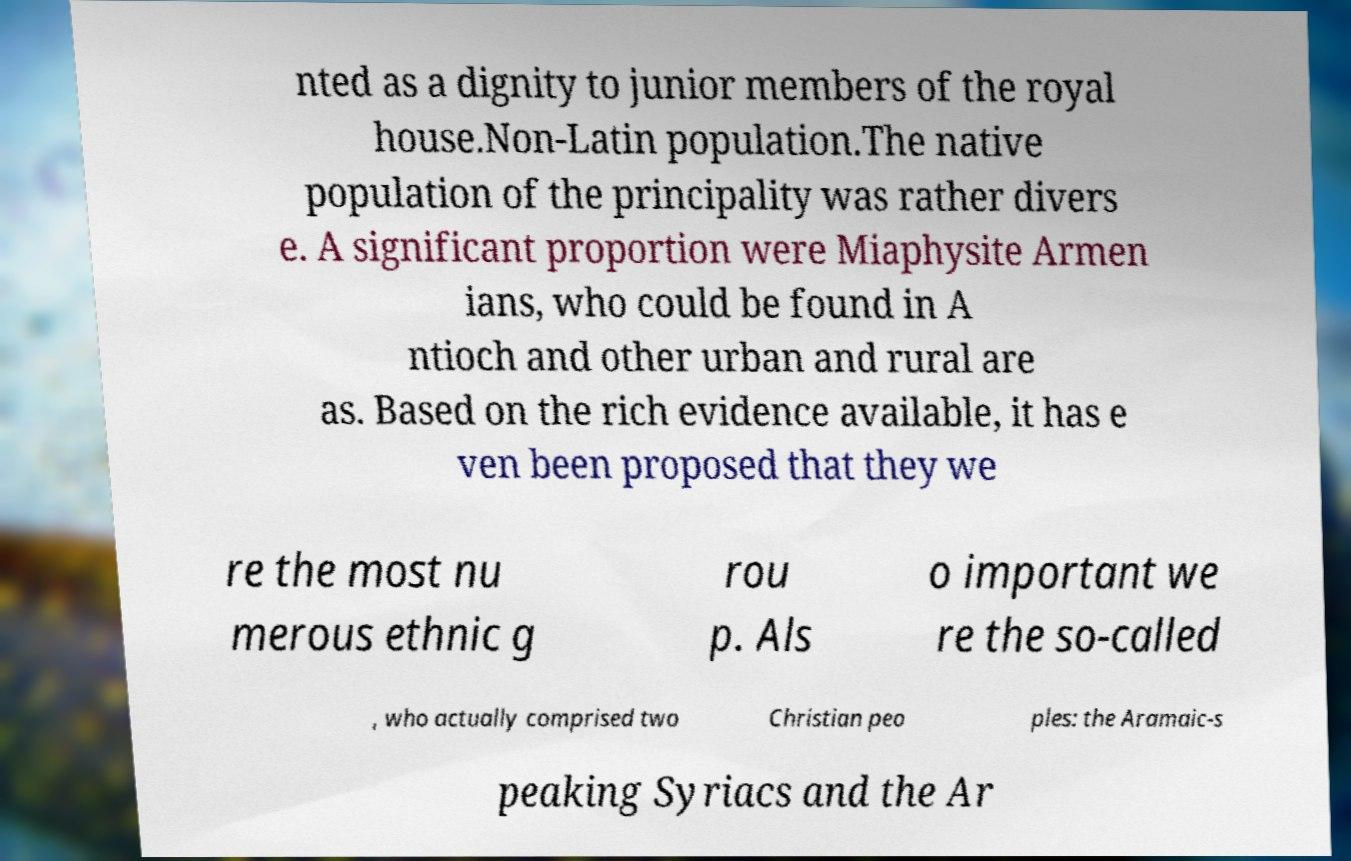Please identify and transcribe the text found in this image. nted as a dignity to junior members of the royal house.Non-Latin population.The native population of the principality was rather divers e. A significant proportion were Miaphysite Armen ians, who could be found in A ntioch and other urban and rural are as. Based on the rich evidence available, it has e ven been proposed that they we re the most nu merous ethnic g rou p. Als o important we re the so-called , who actually comprised two Christian peo ples: the Aramaic-s peaking Syriacs and the Ar 